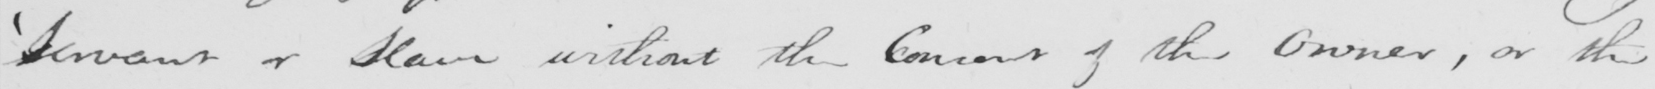What text is written in this handwritten line? ' Servant or Slave without the Consent of the Owner , or the 